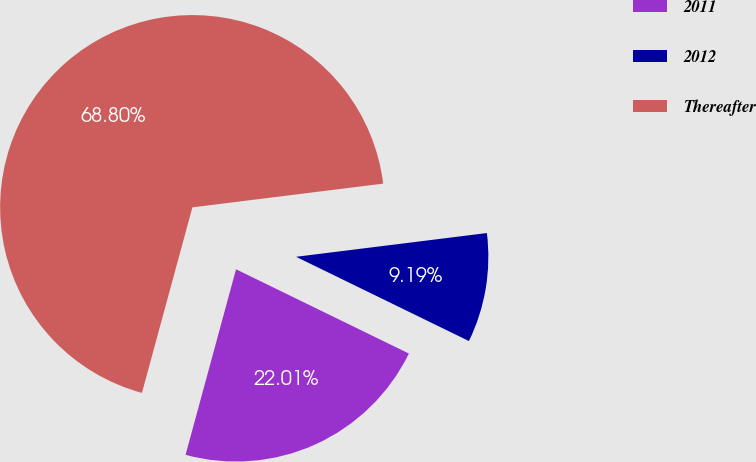Convert chart to OTSL. <chart><loc_0><loc_0><loc_500><loc_500><pie_chart><fcel>2011<fcel>2012<fcel>Thereafter<nl><fcel>22.01%<fcel>9.19%<fcel>68.81%<nl></chart> 